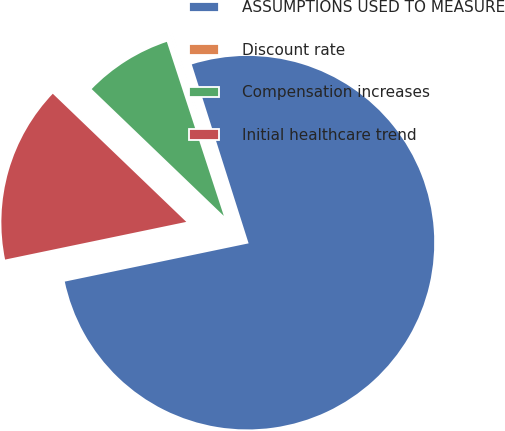Convert chart. <chart><loc_0><loc_0><loc_500><loc_500><pie_chart><fcel>ASSUMPTIONS USED TO MEASURE<fcel>Discount rate<fcel>Compensation increases<fcel>Initial healthcare trend<nl><fcel>76.63%<fcel>0.14%<fcel>7.79%<fcel>15.44%<nl></chart> 